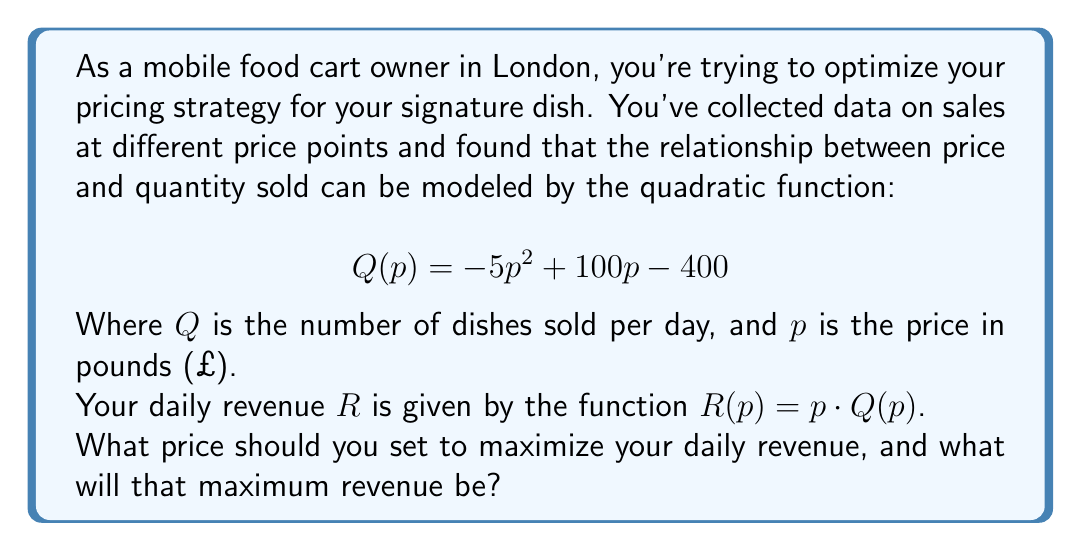What is the answer to this math problem? To solve this problem, we'll follow these steps:

1) First, let's expand the revenue function:
   $$R(p) = p \cdot Q(p) = p(-5p^2 + 100p - 400)$$
   $$R(p) = -5p^3 + 100p^2 - 400p$$

2) To find the maximum revenue, we need to find where the derivative of $R(p)$ equals zero:
   $$R'(p) = -15p^2 + 200p - 400$$

3) Set $R'(p) = 0$ and solve:
   $$-15p^2 + 200p - 400 = 0$$

4) This is a quadratic equation. We can solve it using the quadratic formula:
   $$p = \frac{-b \pm \sqrt{b^2 - 4ac}}{2a}$$
   Where $a=-15$, $b=200$, and $c=-400$

5) Plugging in these values:
   $$p = \frac{-200 \pm \sqrt{200^2 - 4(-15)(-400)}}{2(-15)}$$
   $$= \frac{-200 \pm \sqrt{40000 - 24000}}{-30}$$
   $$= \frac{-200 \pm \sqrt{16000}}{-30}$$
   $$= \frac{-200 \pm 400\sqrt{1}}{-30}$$

6) This gives us two solutions:
   $$p = \frac{-200 + 400}{-30} = \frac{200}{-30} = -\frac{20}{3}$$
   $$p = \frac{-200 - 400}{-30} = \frac{-600}{-30} = 20$$

7) Since price can't be negative, we discard the negative solution. Therefore, the optimal price is £20.

8) To find the maximum revenue, we substitute this price back into our original revenue function:
   $$R(20) = -5(20)^3 + 100(20)^2 - 400(20)$$
   $$= -40000 + 40000 - 8000 = -8000$$

Therefore, the maximum daily revenue is £8,000.
Answer: The optimal price to maximize daily revenue is £20, and the maximum daily revenue at this price is £8,000. 